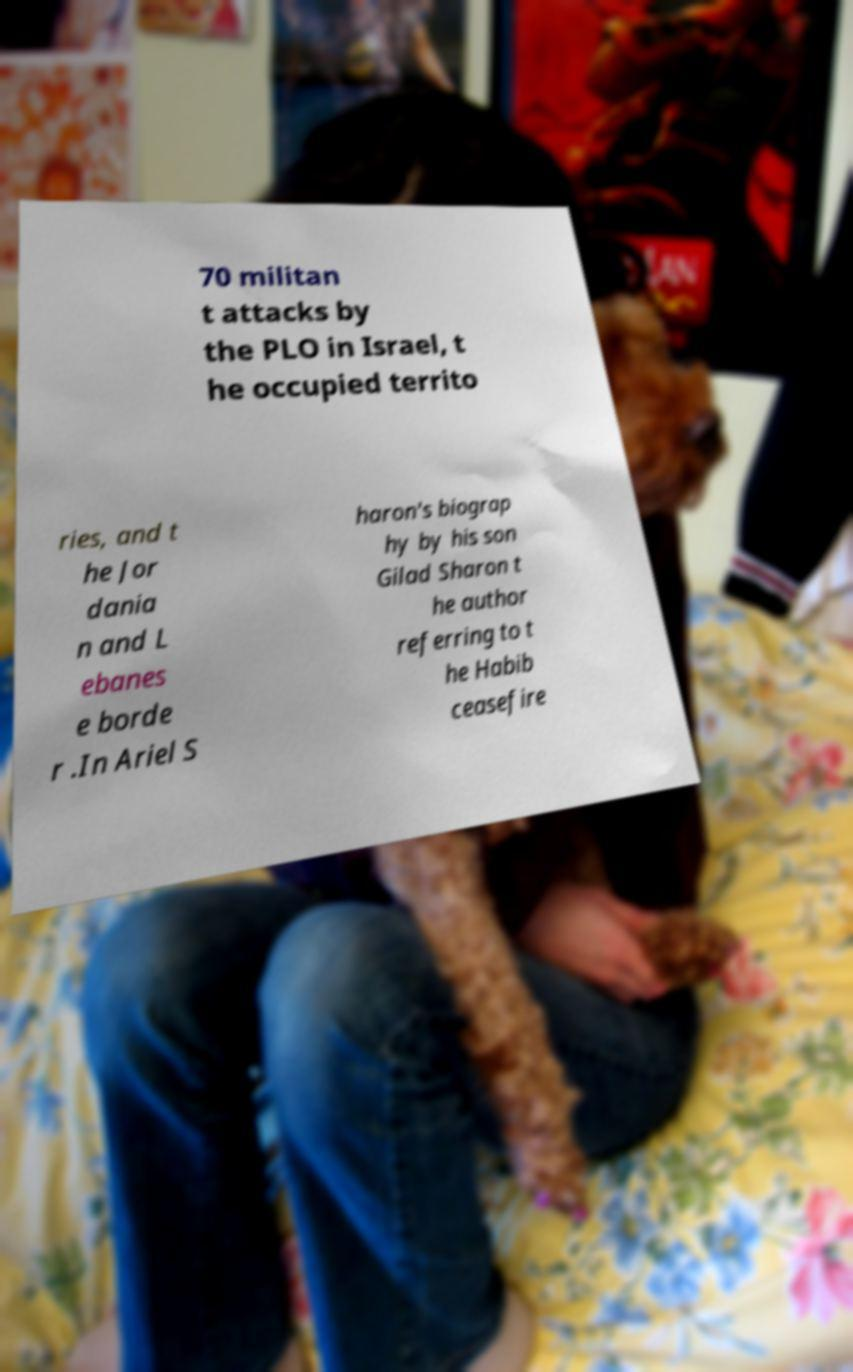Could you extract and type out the text from this image? 70 militan t attacks by the PLO in Israel, t he occupied territo ries, and t he Jor dania n and L ebanes e borde r .In Ariel S haron's biograp hy by his son Gilad Sharon t he author referring to t he Habib ceasefire 